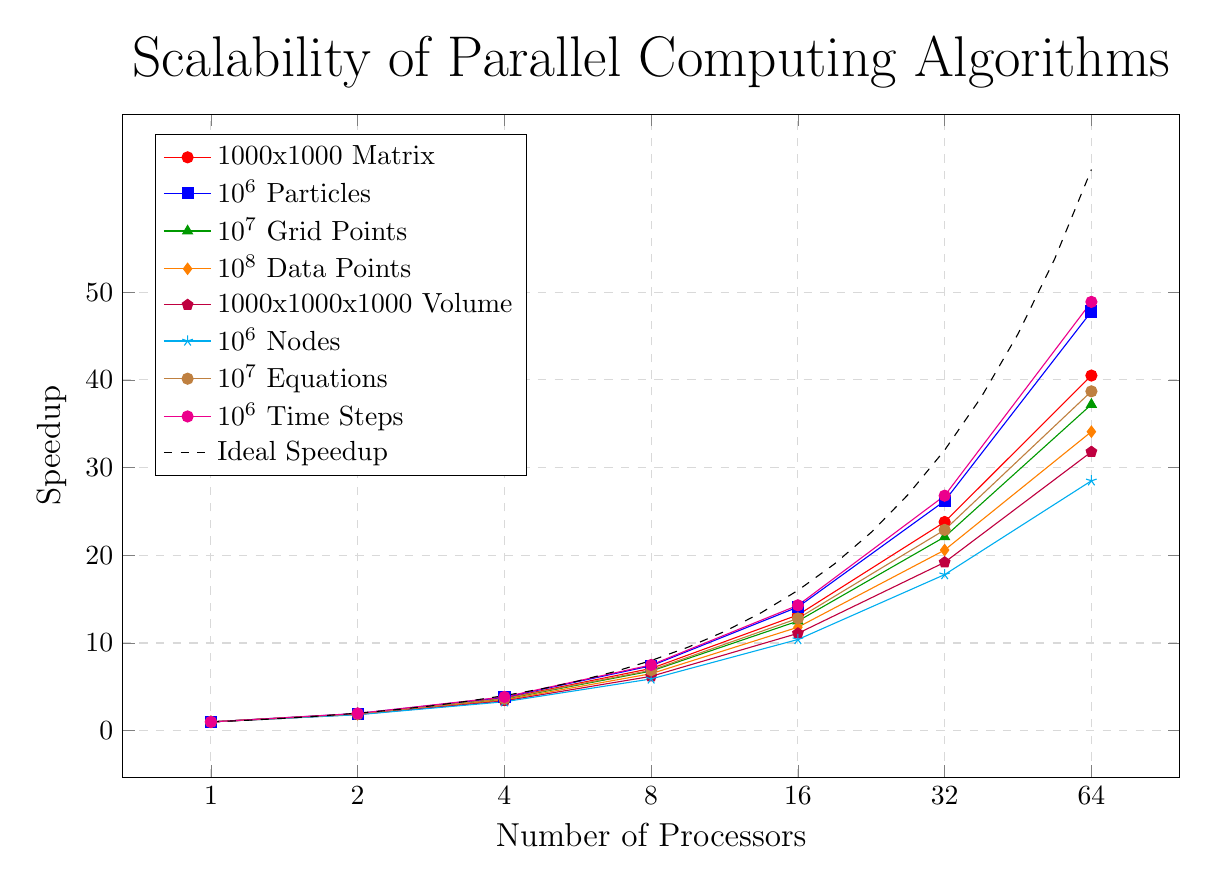What's the ideal speedup when using 16 processors? The ideal speedup is represented by the dashed black line, which is a direct diagonal, suggesting a linear relationship where speedup equals the number of processors used. For 16 processors, the ideal speedup is thus 16.
Answer: 16 Which algorithm has the highest speedup with 64 processors? From the figure, the highest speedup among all the plotted algorithms with 64 processors is for "10^6 Time Steps, N-Body Simulation," where it reaches a speedup of 48.9.
Answer: 10^6 Time Steps, N-Body Simulation What is the speedup of the "Parallel Quicksort" algorithm with 32 processors? Finding the "Parallel Quicksort" algorithm (labelled as "10^8 Data Points" in the legend) in the plot, the speedup with 32 processors is 20.6.
Answer: 20.6 How does the speedup of "Finite Element Analysis" with 8 processors compare to "Graph Traversal (BFS)" with 16 processors? From the plot, "Finite Element Analysis" (labelled as "10^7 Grid Points") with 8 processors has a speedup of 6.8. "Graph Traversal (BFS)" (labelled as "10^6 Nodes") with 16 processors has a speedup of 10.4. Thus, 10.4 is higher than 6.8.
Answer: Speedup of Graph Traversal (BFS) with 16 processors is higher Which algorithm has the lowest speedup when using 32 processors, and what is this value? The algorithm with the lowest speedup for 32 processors is "Graph Traversal (BFS)" (labelled as "10^6 Nodes"), with a speedup value of 17.8.
Answer: Graph Traversal (BFS), 17.8 What is the difference in speedup between the "3D FFT" algorithm with 8 processors and "Parallel Matrix Multiplication" with 8 processors? From the plot, the speedup for "3D FFT" (labelled as "1000x1000x1000 Volume") with 8 processors is 6.2. The speedup for "Parallel Matrix Multiplication" (labelled as "1000x1000 Matrix") with 8 processors is 7.1. The difference is 7.1 - 6.2 = 0.9.
Answer: 0.9 Which algorithm's speedup approaches the ideal speedup the closest when using 64 processors? Comparing all the algorithms, "10^6 Time Steps, N-Body Simulation" has the speedup of 48.9 when using 64 processors, which seems to be the closest to the ideal speedup line for 64 processors.
Answer: 10^6 Time Steps, N-Body Simulation Do any algorithms fail to achieve a speedup of 10 with 32 processors? By observing the algorithms' performance at 32 processors, all of them achieve more than a speedup of 10, hence none of the algorithms fail to achieve a speedup of 10 with 32 processors.
Answer: No For the "Molecular Dynamics Simulation" algorithm, how does the speedup change when the processors increase from 8 to 16? The "Molecular Dynamics Simulation" (labelled as "10^6 Particles") speedup with 8 processors is 7.4, and with 16 processors, it is 14.1. The change in speedup is 14.1 - 7.4 = 6.7.
Answer: 6.7 Is the performance of "Conjugate Gradient Method" better or worse than "Parallel Quicksort" at 64 processors? At 64 processors, the "Conjugate Gradient Method" (labelled as "10^7 Equations") has a speedup of 38.7, while "Parallel Quicksort" (labelled as "10^8 Data Points") has a speedup of 34.1. Therefore, the performance of "Conjugate Gradient Method" is better.
Answer: Better 